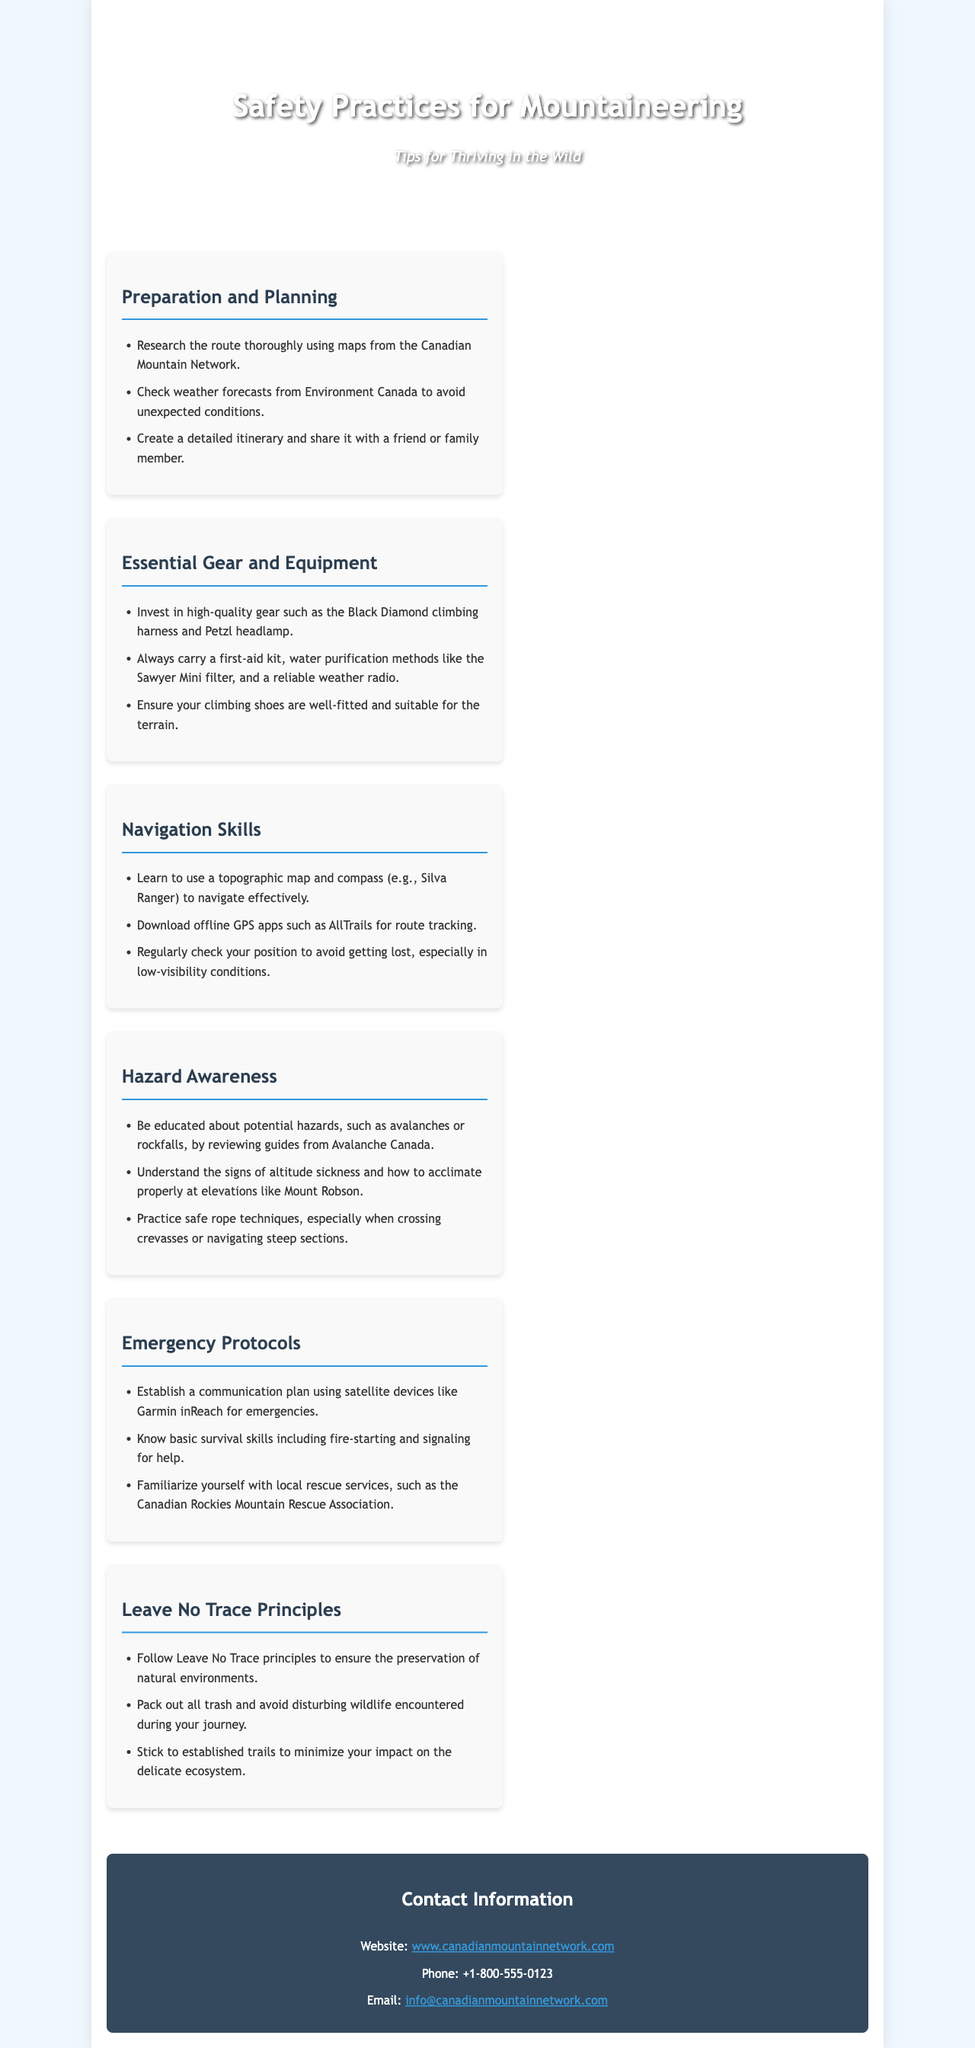What are the essential gear recommendations? The document lists several essential gear including the Black Diamond climbing harness and Petzl headlamp.
Answer: Black Diamond climbing harness and Petzl headlamp Which organization provides weather forecasts mentioned? The document refers to Environment Canada for checking weather forecasts.
Answer: Environment Canada What is the recommended action to avoid unexpected conditions? The text suggests checking weather forecasts to avoid unexpected conditions during mountaineering.
Answer: Check weather forecasts What is advised to ensure navigation skills? The document suggests learning to use a topographic map and compass to enhance navigation skills.
Answer: Topographic map and compass What should you establish for emergency protocols? Establishing a communication plan using satellite devices is advised in the document.
Answer: Communication plan Name one principle from the Leave No Trace guidelines. One of the principles includes following Leave No Trace principles for environmental preservation.
Answer: Leave No Trace principles Why is it important to share your itinerary? The document states that sharing a detailed itinerary with a friend or family member is important for safety.
Answer: Safety What is suggested to carry for water purification? The document recommends carrying a Sawyer Mini filter for water purification.
Answer: Sawyer Mini filter Which rescue service is mentioned for emergencies? The Canadian Rockies Mountain Rescue Association is mentioned as a local rescue service in case of emergencies.
Answer: Canadian Rockies Mountain Rescue Association 